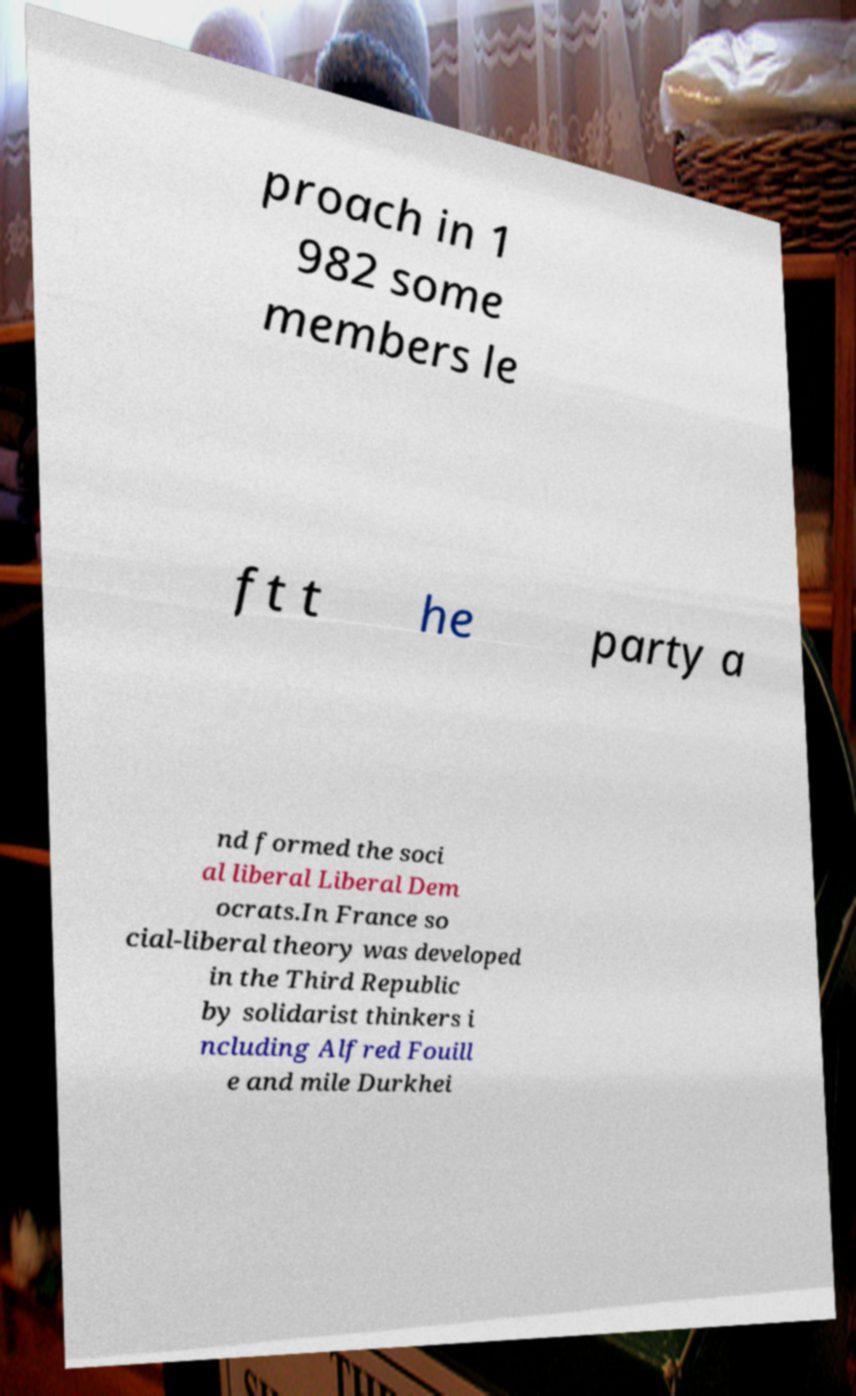Could you extract and type out the text from this image? proach in 1 982 some members le ft t he party a nd formed the soci al liberal Liberal Dem ocrats.In France so cial-liberal theory was developed in the Third Republic by solidarist thinkers i ncluding Alfred Fouill e and mile Durkhei 